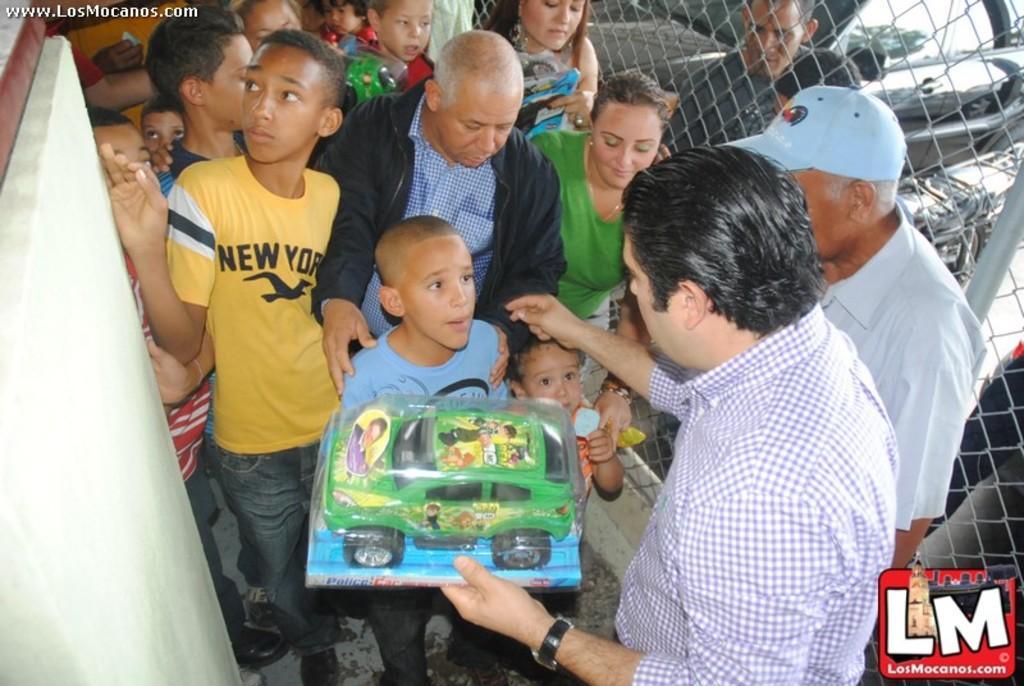Please provide a concise description of this image. Here we can see amish, people and vehicles. These people are holding toy cars. Left side corner of the image there is a watermark. Right side bottom of the image there is a logo. 